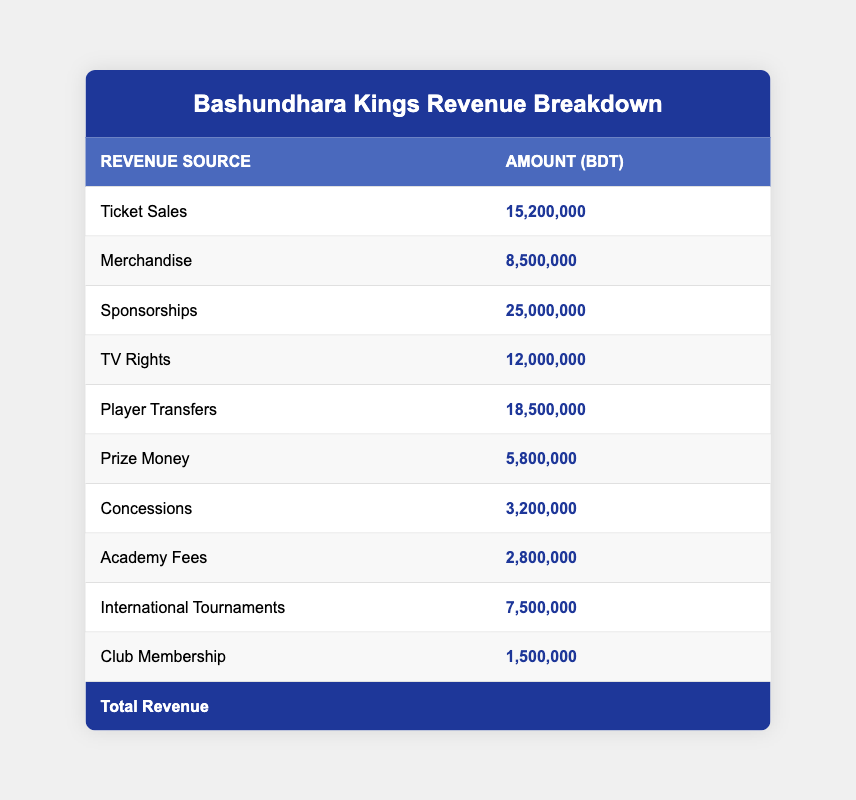What was the total revenue for Bashundhara Kings in the previous fiscal year? To find the total revenue, we look at the last row of the table which explicitly states the total revenue as 100,000,000 BDT.
Answer: 100,000,000 BDT Which revenue source generated the highest amount? By inspecting the table, we see that Sponsorships have the highest amount listed, which is 25,000,000 BDT.
Answer: Sponsorships What is the combined revenue from Ticket Sales and Merchandise? We sum the amounts from the Ticket Sales (15,200,000 BDT) and Merchandise (8,500,000 BDT): 15,200,000 + 8,500,000 = 23,700,000 BDT.
Answer: 23,700,000 BDT Did the Bashundhara Kings earn more from Player Transfers than from Prize Money? We compare Player Transfers, which is 18,500,000 BDT, and Prize Money, which is 5,800,000 BDT. Since 18,500,000 is greater than 5,800,000, the statement is true.
Answer: Yes What is the average revenue from all sources listed in the table? We need to sum all revenue amounts: 15,200,000 + 8,500,000 + 25,000,000 + 12,000,000 + 18,500,000 + 5,800,000 + 3,200,000 + 2,800,000 + 7,500,000 + 1,500,000 = 100,000,000 BDT. There are 10 sources, so the average is 100,000,000 / 10 = 10,000,000 BDT.
Answer: 10,000,000 BDT What revenue sources contributed less than 10,000,000 BDT? By evaluating each amount, we identify the following sources: Merchandise (8,500,000 BDT), Prize Money (5,800,000 BDT), Concessions (3,200,000 BDT), Academy Fees (2,800,000 BDT), and Club Membership (1,500,000 BDT). Therefore, the sources that contributed less than 10,000,000 BDT are five in number.
Answer: Five sources How much revenue did Bashundhara Kings earn from TV Rights compared to International Tournaments? The revenue from TV Rights is 12,000,000 BDT, while International Tournaments generated 7,500,000 BDT. We can affirm that 12,000,000 is greater than 7,500,000.
Answer: TV Rights earned more What is the total revenue generated from concessions and academy fees? To find this, we add the Concessions (3,200,000 BDT) and Academy Fees (2,800,000 BDT): 3,200,000 + 2,800,000 = 6,000,000 BDT.
Answer: 6,000,000 BDT 